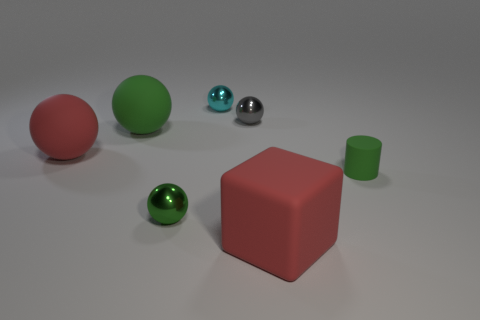Is there any other thing that is the same shape as the green metallic thing?
Provide a succinct answer. Yes. How many blocks are either tiny blue metallic objects or cyan shiny things?
Ensure brevity in your answer.  0. What number of big red rubber things are there?
Your answer should be compact. 2. There is a green rubber thing that is in front of the red matte object that is behind the big red matte block; what is its size?
Your response must be concise. Small. How many other things are there of the same size as the red block?
Provide a short and direct response. 2. What number of small green matte objects are on the right side of the tiny cyan shiny ball?
Your answer should be compact. 1. The red ball has what size?
Your answer should be compact. Large. Are the large red object that is on the left side of the gray sphere and the big red thing right of the small cyan thing made of the same material?
Your answer should be very brief. Yes. Is there a metal object that has the same color as the tiny rubber cylinder?
Keep it short and to the point. Yes. There is a matte block that is the same size as the red ball; what is its color?
Your answer should be very brief. Red. 